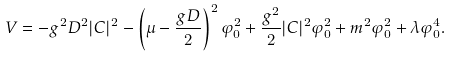Convert formula to latex. <formula><loc_0><loc_0><loc_500><loc_500>V = - g ^ { 2 } D ^ { 2 } | C | ^ { 2 } - \left ( \mu - \frac { g D } { 2 } \right ) ^ { 2 } \varphi _ { 0 } ^ { 2 } + \frac { g ^ { 2 } } { 2 } | C | ^ { 2 } \varphi _ { 0 } ^ { 2 } + m ^ { 2 } \varphi _ { 0 } ^ { 2 } + \lambda \varphi _ { 0 } ^ { 4 } .</formula> 